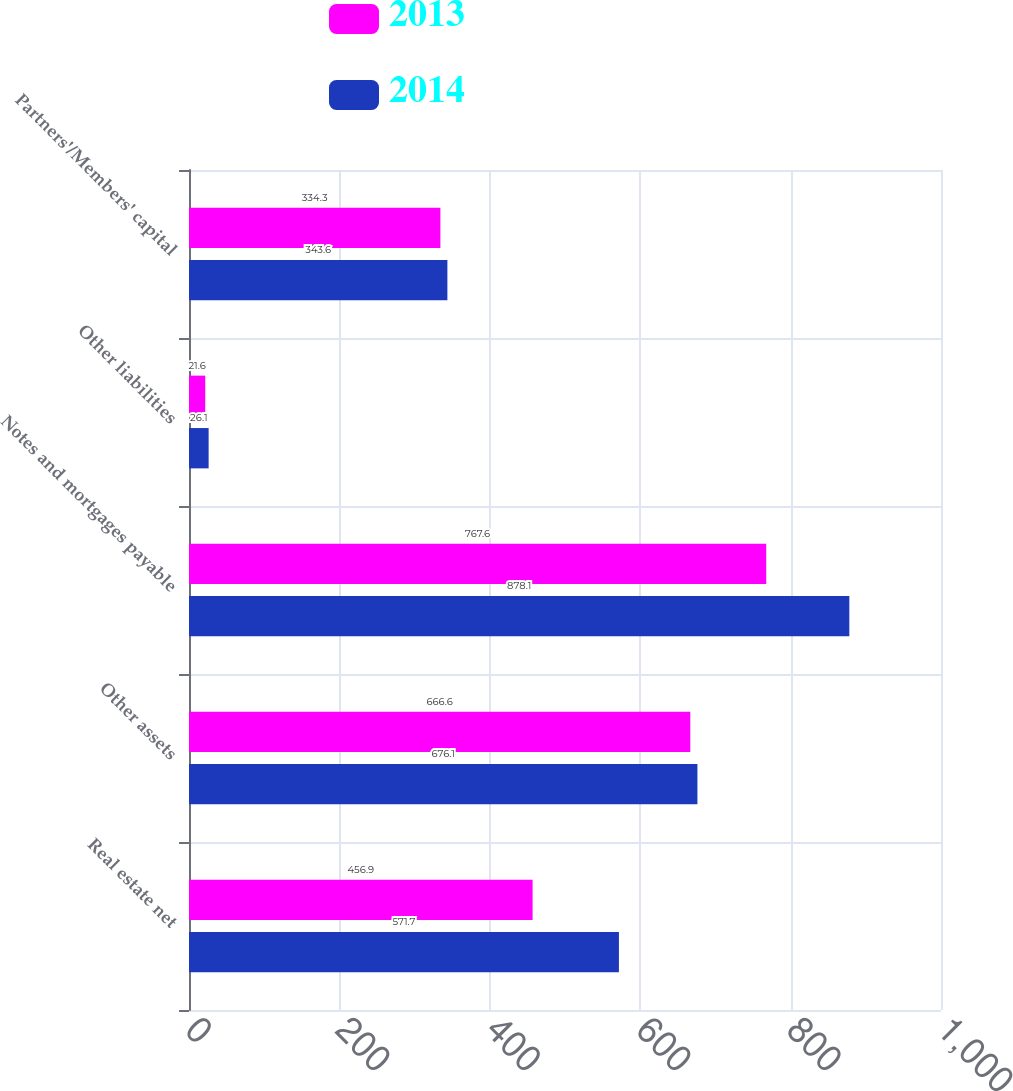Convert chart. <chart><loc_0><loc_0><loc_500><loc_500><stacked_bar_chart><ecel><fcel>Real estate net<fcel>Other assets<fcel>Notes and mortgages payable<fcel>Other liabilities<fcel>Partners'/Members' capital<nl><fcel>2013<fcel>456.9<fcel>666.6<fcel>767.6<fcel>21.6<fcel>334.3<nl><fcel>2014<fcel>571.7<fcel>676.1<fcel>878.1<fcel>26.1<fcel>343.6<nl></chart> 